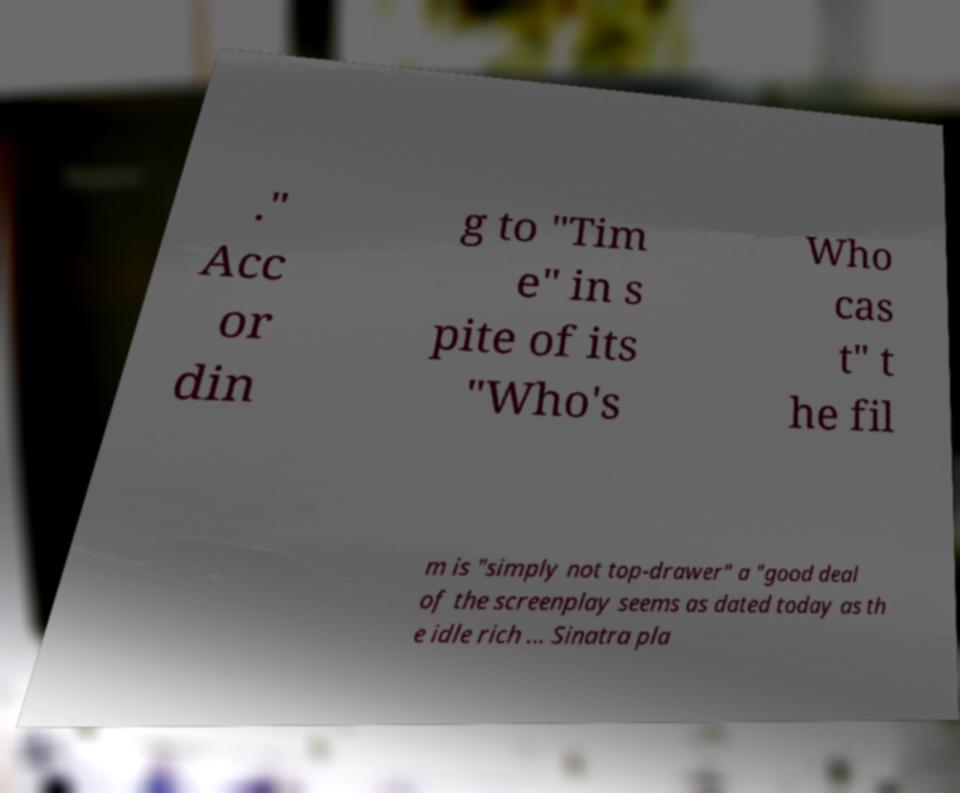Please identify and transcribe the text found in this image. ." Acc or din g to "Tim e" in s pite of its "Who's Who cas t" t he fil m is "simply not top-drawer" a "good deal of the screenplay seems as dated today as th e idle rich ... Sinatra pla 